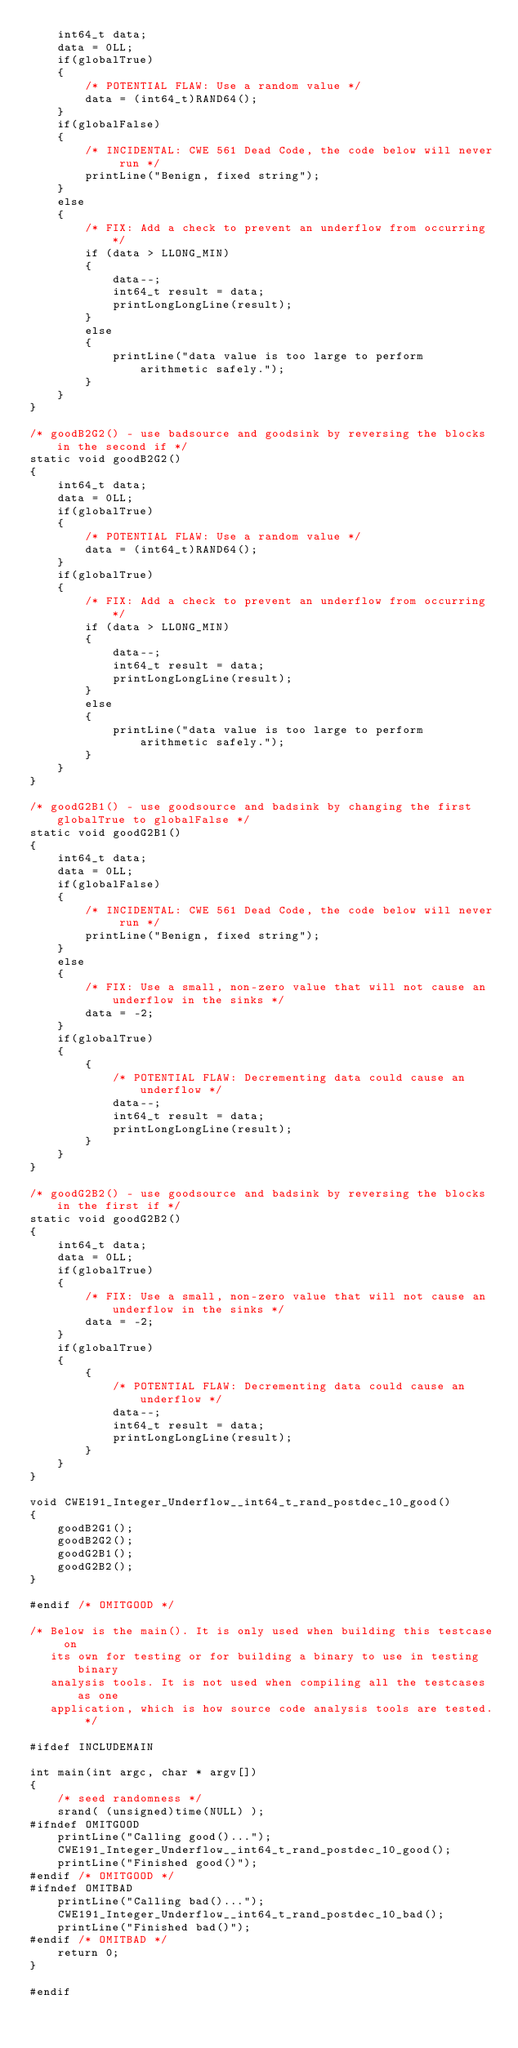Convert code to text. <code><loc_0><loc_0><loc_500><loc_500><_C_>    int64_t data;
    data = 0LL;
    if(globalTrue)
    {
        /* POTENTIAL FLAW: Use a random value */
        data = (int64_t)RAND64();
    }
    if(globalFalse)
    {
        /* INCIDENTAL: CWE 561 Dead Code, the code below will never run */
        printLine("Benign, fixed string");
    }
    else
    {
        /* FIX: Add a check to prevent an underflow from occurring */
        if (data > LLONG_MIN)
        {
            data--;
            int64_t result = data;
            printLongLongLine(result);
        }
        else
        {
            printLine("data value is too large to perform arithmetic safely.");
        }
    }
}

/* goodB2G2() - use badsource and goodsink by reversing the blocks in the second if */
static void goodB2G2()
{
    int64_t data;
    data = 0LL;
    if(globalTrue)
    {
        /* POTENTIAL FLAW: Use a random value */
        data = (int64_t)RAND64();
    }
    if(globalTrue)
    {
        /* FIX: Add a check to prevent an underflow from occurring */
        if (data > LLONG_MIN)
        {
            data--;
            int64_t result = data;
            printLongLongLine(result);
        }
        else
        {
            printLine("data value is too large to perform arithmetic safely.");
        }
    }
}

/* goodG2B1() - use goodsource and badsink by changing the first globalTrue to globalFalse */
static void goodG2B1()
{
    int64_t data;
    data = 0LL;
    if(globalFalse)
    {
        /* INCIDENTAL: CWE 561 Dead Code, the code below will never run */
        printLine("Benign, fixed string");
    }
    else
    {
        /* FIX: Use a small, non-zero value that will not cause an underflow in the sinks */
        data = -2;
    }
    if(globalTrue)
    {
        {
            /* POTENTIAL FLAW: Decrementing data could cause an underflow */
            data--;
            int64_t result = data;
            printLongLongLine(result);
        }
    }
}

/* goodG2B2() - use goodsource and badsink by reversing the blocks in the first if */
static void goodG2B2()
{
    int64_t data;
    data = 0LL;
    if(globalTrue)
    {
        /* FIX: Use a small, non-zero value that will not cause an underflow in the sinks */
        data = -2;
    }
    if(globalTrue)
    {
        {
            /* POTENTIAL FLAW: Decrementing data could cause an underflow */
            data--;
            int64_t result = data;
            printLongLongLine(result);
        }
    }
}

void CWE191_Integer_Underflow__int64_t_rand_postdec_10_good()
{
    goodB2G1();
    goodB2G2();
    goodG2B1();
    goodG2B2();
}

#endif /* OMITGOOD */

/* Below is the main(). It is only used when building this testcase on
   its own for testing or for building a binary to use in testing binary
   analysis tools. It is not used when compiling all the testcases as one
   application, which is how source code analysis tools are tested. */

#ifdef INCLUDEMAIN

int main(int argc, char * argv[])
{
    /* seed randomness */
    srand( (unsigned)time(NULL) );
#ifndef OMITGOOD
    printLine("Calling good()...");
    CWE191_Integer_Underflow__int64_t_rand_postdec_10_good();
    printLine("Finished good()");
#endif /* OMITGOOD */
#ifndef OMITBAD
    printLine("Calling bad()...");
    CWE191_Integer_Underflow__int64_t_rand_postdec_10_bad();
    printLine("Finished bad()");
#endif /* OMITBAD */
    return 0;
}

#endif
</code> 